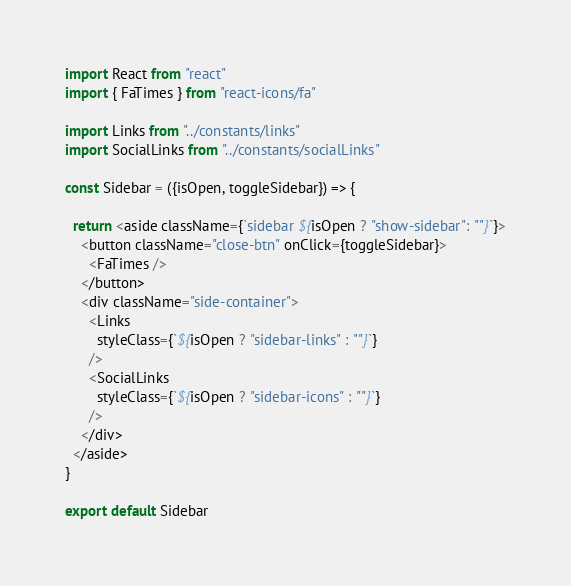<code> <loc_0><loc_0><loc_500><loc_500><_JavaScript_>import React from "react"
import { FaTimes } from "react-icons/fa"

import Links from "../constants/links"
import SocialLinks from "../constants/socialLinks"

const Sidebar = ({isOpen, toggleSidebar}) => {

  return <aside className={`sidebar ${isOpen ? "show-sidebar": ""}`}>
    <button className="close-btn" onClick={toggleSidebar}>
      <FaTimes />
    </button>
    <div className="side-container">
      <Links 
        styleClass={`${isOpen ? "sidebar-links" : ""}`} 
      />
      <SocialLinks 
        styleClass={`${isOpen ? "sidebar-icons" : ""}`}  
      />
    </div>
  </aside>
}

export default Sidebar
</code> 